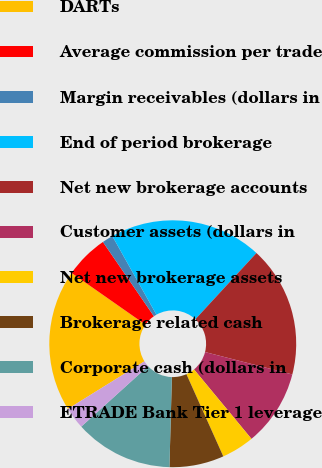Convert chart to OTSL. <chart><loc_0><loc_0><loc_500><loc_500><pie_chart><fcel>DARTs<fcel>Average commission per trade<fcel>Margin receivables (dollars in<fcel>End of period brokerage<fcel>Net new brokerage accounts<fcel>Customer assets (dollars in<fcel>Net new brokerage assets<fcel>Brokerage related cash<fcel>Corporate cash (dollars in<fcel>ETRADE Bank Tier 1 leverage<nl><fcel>18.57%<fcel>5.71%<fcel>1.43%<fcel>20.0%<fcel>17.14%<fcel>10.0%<fcel>4.29%<fcel>7.14%<fcel>12.86%<fcel>2.86%<nl></chart> 